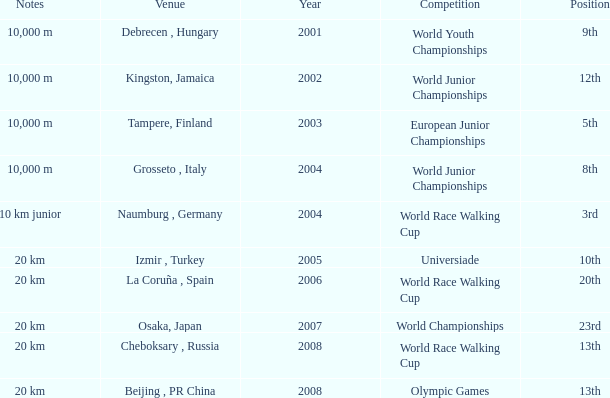In which venue did he place 3rd in the World Race Walking Cup? Naumburg , Germany. 